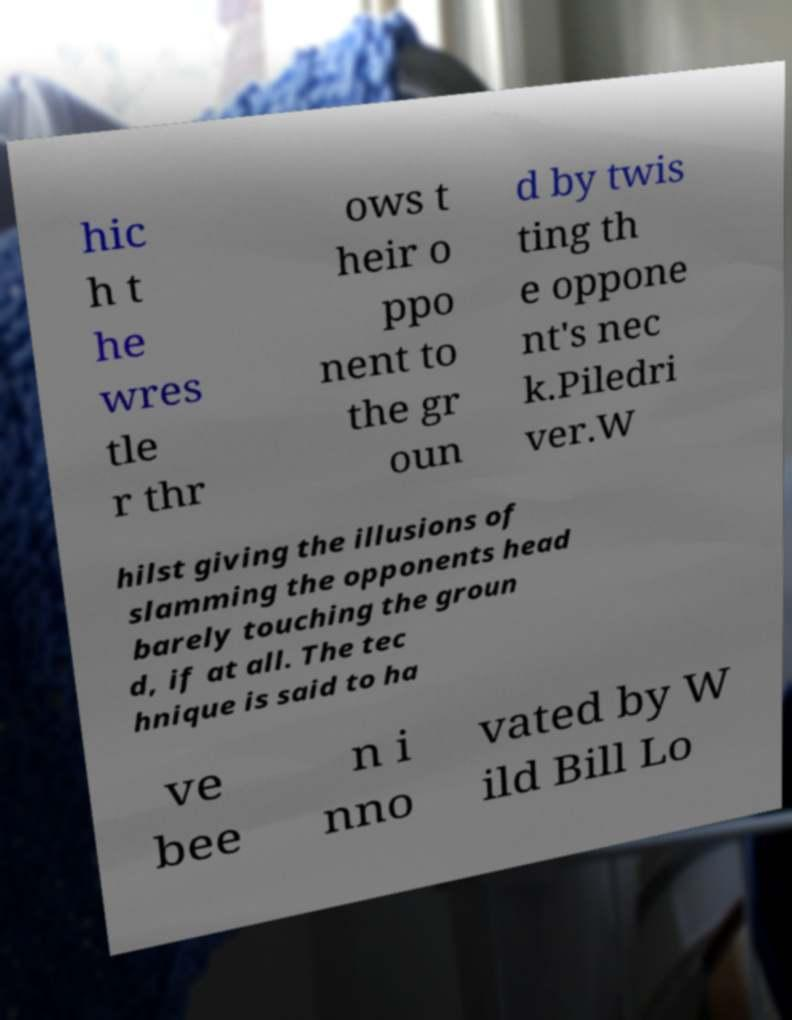Can you read and provide the text displayed in the image?This photo seems to have some interesting text. Can you extract and type it out for me? hic h t he wres tle r thr ows t heir o ppo nent to the gr oun d by twis ting th e oppone nt's nec k.Piledri ver.W hilst giving the illusions of slamming the opponents head barely touching the groun d, if at all. The tec hnique is said to ha ve bee n i nno vated by W ild Bill Lo 